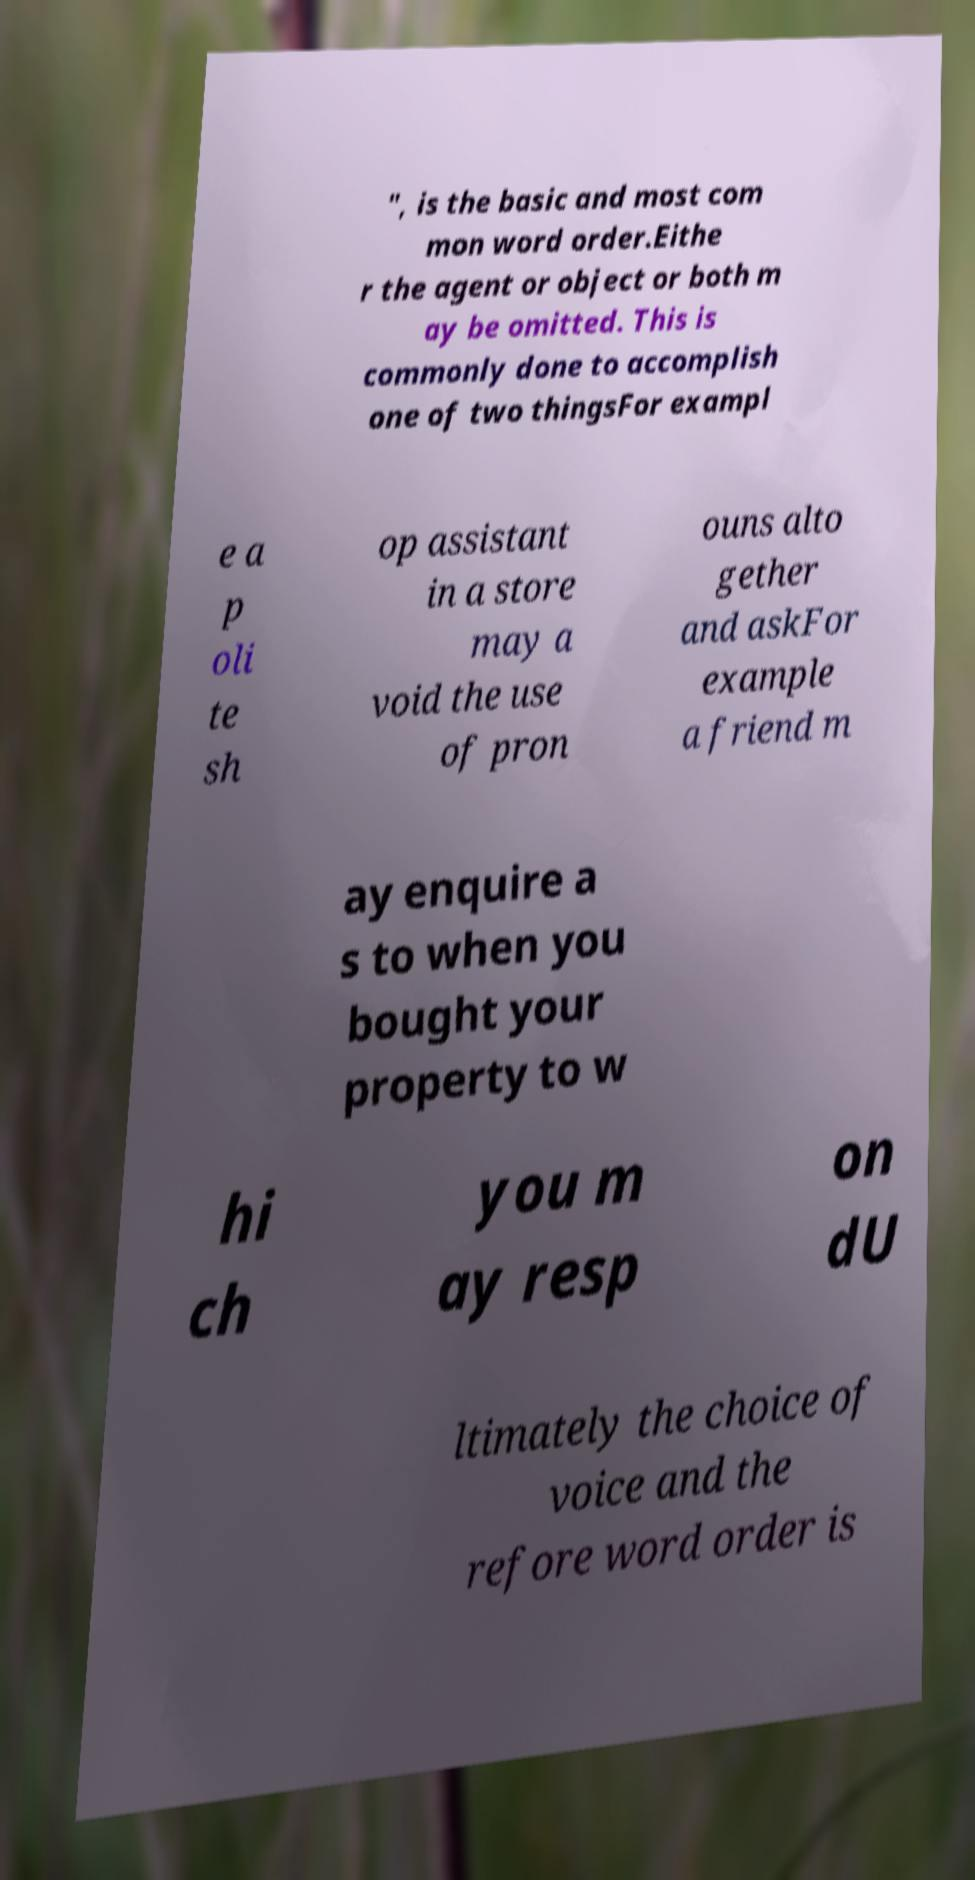Please identify and transcribe the text found in this image. ", is the basic and most com mon word order.Eithe r the agent or object or both m ay be omitted. This is commonly done to accomplish one of two thingsFor exampl e a p oli te sh op assistant in a store may a void the use of pron ouns alto gether and askFor example a friend m ay enquire a s to when you bought your property to w hi ch you m ay resp on dU ltimately the choice of voice and the refore word order is 